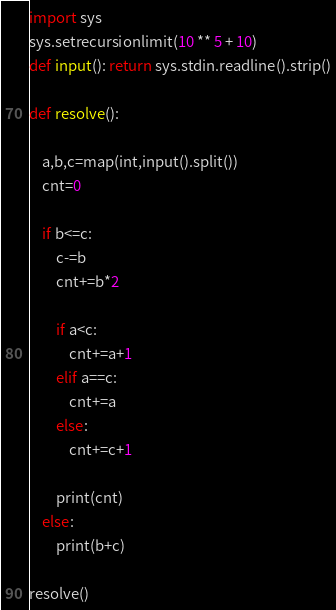<code> <loc_0><loc_0><loc_500><loc_500><_Python_>import sys
sys.setrecursionlimit(10 ** 5 + 10)
def input(): return sys.stdin.readline().strip()

def resolve():

    a,b,c=map(int,input().split())
    cnt=0

    if b<=c:
        c-=b
        cnt+=b*2

        if a<c:
            cnt+=a+1
        elif a==c:
            cnt+=a
        else:
            cnt+=c+1

        print(cnt)
    else:
        print(b+c)

resolve()</code> 